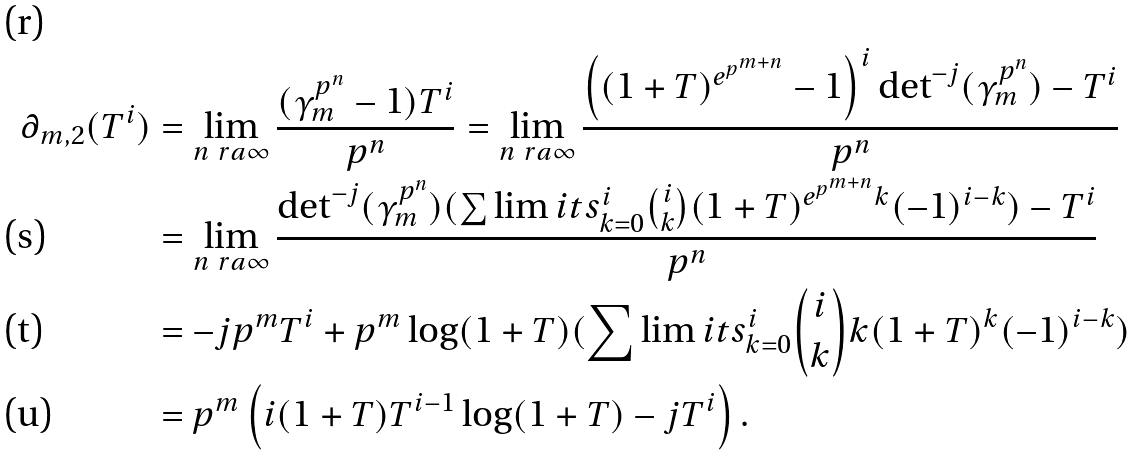<formula> <loc_0><loc_0><loc_500><loc_500>\partial _ { m , 2 } ( T ^ { i } ) & = \lim _ { n \ r a \infty } \frac { ( \gamma _ { m } ^ { p ^ { n } } - 1 ) T ^ { i } } { p ^ { n } } = \lim _ { n \ r a \infty } \frac { \left ( ( 1 + T ) ^ { e ^ { p ^ { m + n } } } - 1 \right ) ^ { i } \det ^ { - j } ( \gamma _ { m } ^ { p ^ { n } } ) - T ^ { i } } { p ^ { n } } \\ & = \lim _ { n \ r a \infty } \frac { \det ^ { - j } ( \gamma _ { m } ^ { p ^ { n } } ) ( \sum \lim i t s _ { k = 0 } ^ { i } \binom { i } { k } ( 1 + T ) ^ { e ^ { p ^ { m + n } } k } ( - 1 ) ^ { i - k } ) - T ^ { i } } { p ^ { n } } \\ & = - j p ^ { m } T ^ { i } + p ^ { m } \log ( 1 + T ) ( \sum \lim i t s _ { k = 0 } ^ { i } \binom { i } { k } k ( 1 + T ) ^ { k } ( - 1 ) ^ { i - k } ) \\ & = p ^ { m } \left ( i ( 1 + T ) T ^ { i - 1 } \log ( 1 + T ) - j T ^ { i } \right ) .</formula> 